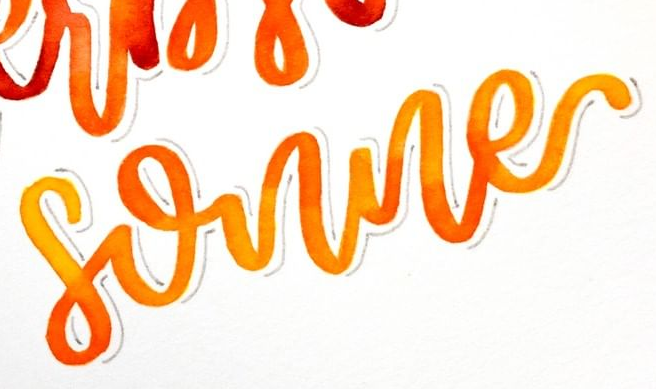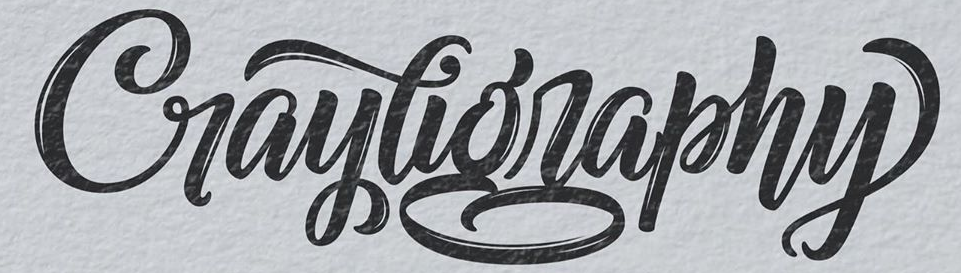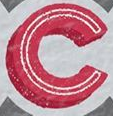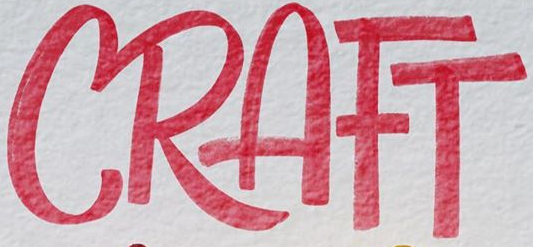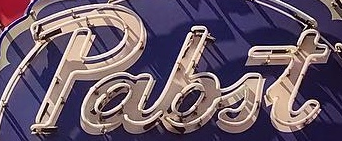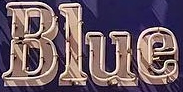Transcribe the words shown in these images in order, separated by a semicolon. sonne; Craytigraphy; C; CRAFT; pabit; Blue 